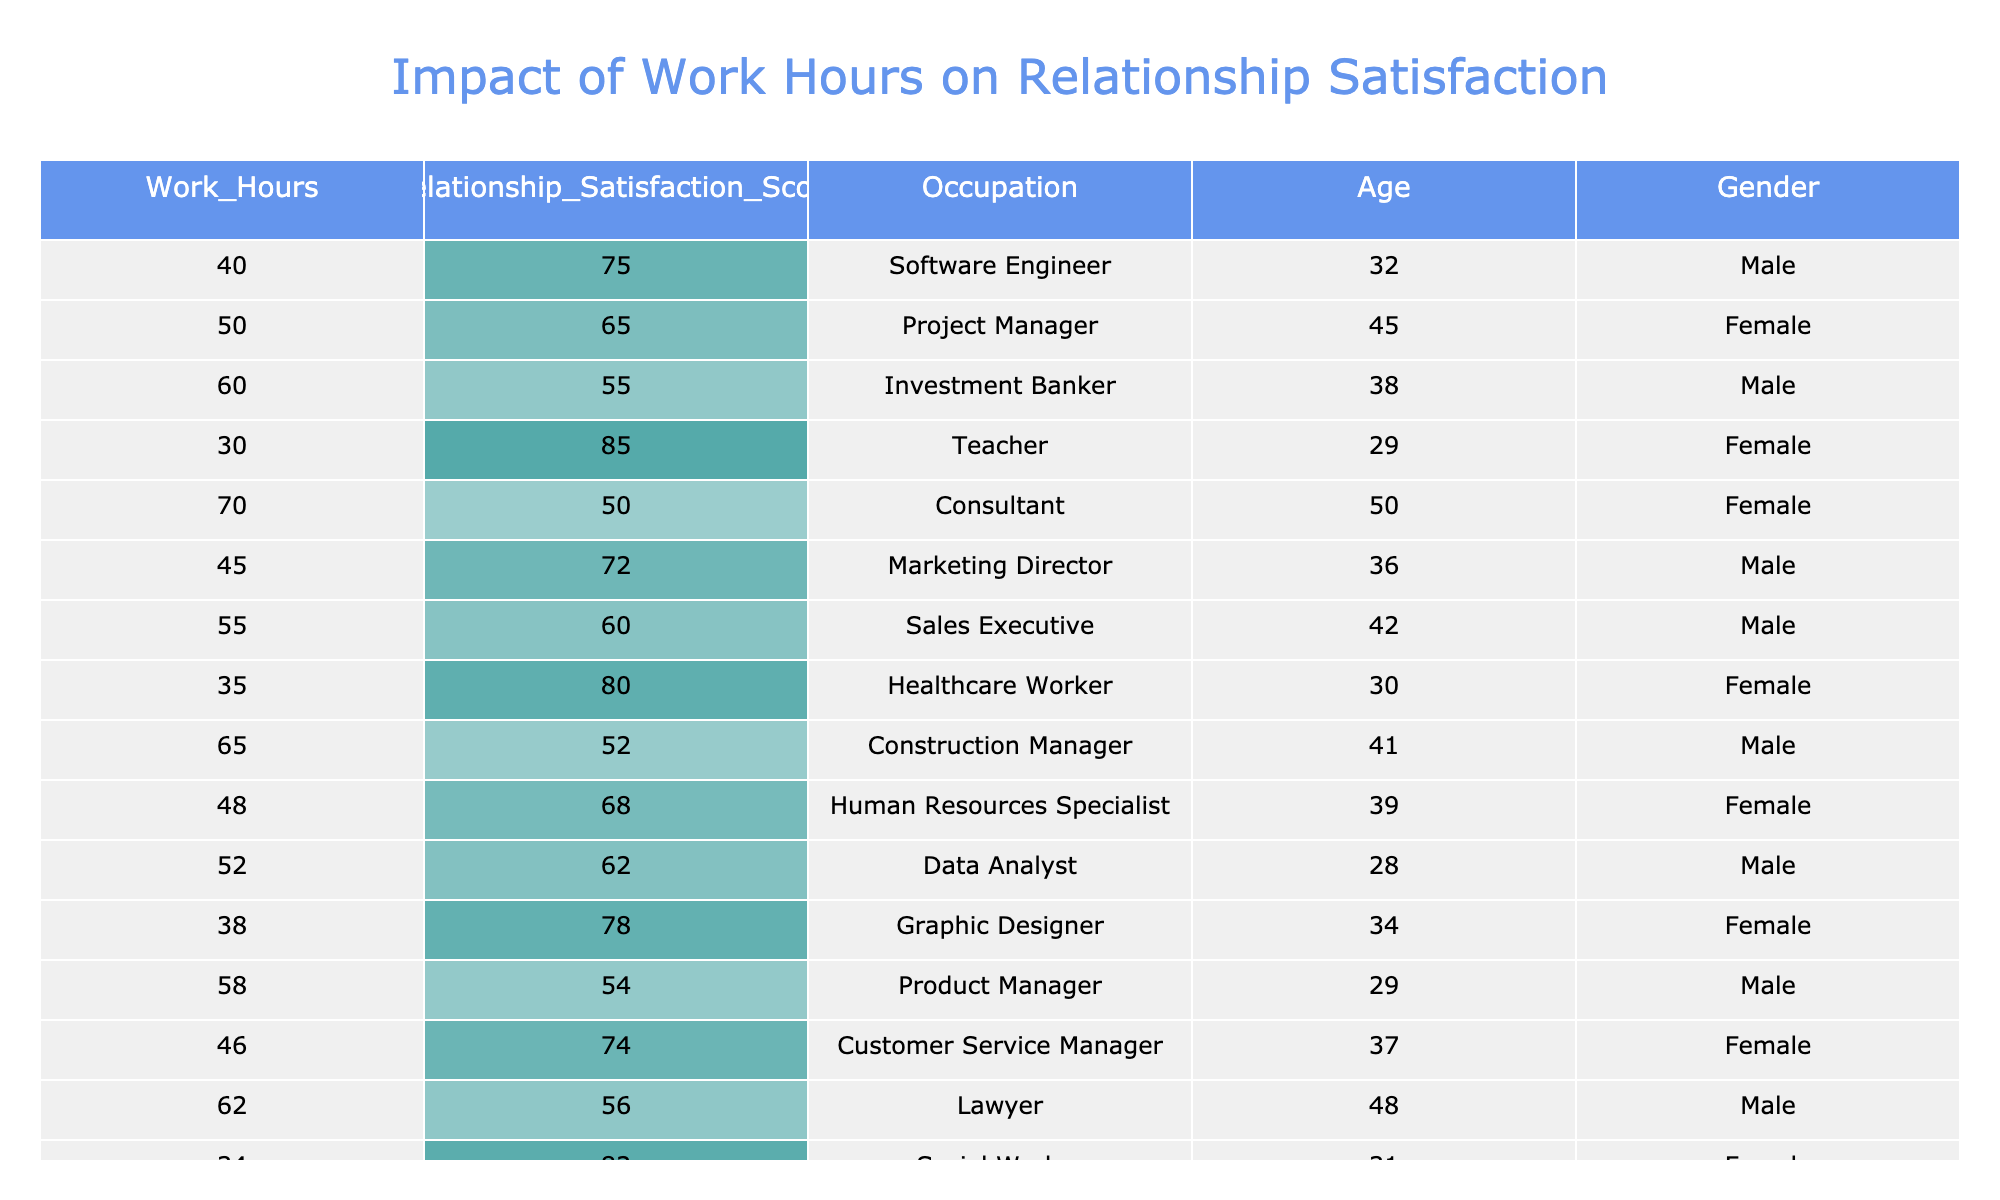What is the highest Relationship Satisfaction Score, and which occupation does it belong to? The highest score in the table is 85, which can be located in the first column of the respective row. The occupation associated with this score is "Teacher."
Answer: 85, Teacher What is the average Relationship Satisfaction Score for individuals working more than 50 hours? First, identify the scores for those who work more than 50 hours: 65, 55, 50, 68, 62, 56, and 54. Adding these gives 65 + 55 + 50 + 68 + 62 + 56 + 54 = 410. There are 7 individuals, so the average is 410 / 7 = 58.57.
Answer: 58.57 Is there a notable relationship between the number of work hours and relationship satisfaction scores? By observing the table, higher work hours generally coincide with lower relationship satisfaction scores, indicating that increased work hours may negatively impact satisfaction.
Answer: Yes How many males have a Relationship Satisfaction Score above 70? Review the scores for males: 75, 65, 55, 72, 60, 52, 54, and 56. The scores above 70 are 75 and 72, which gives a total of 2 males.
Answer: 2 What is the difference in Relationship Satisfaction Scores between the individual with the highest and lowest scores? The highest score is 85 (Teacher) and the lowest score is 50 (Consultant). The difference is calculated as 85 - 50 = 35.
Answer: 35 How does the average Relationship Satisfaction Score for females compare to that of males? For females, the scores are 65, 80, 85, 68, 78, 74, 82, which sum to 457. There are 7 females giving an average of 457 / 7 = 65.29. Males have scores 75, 55, 72, 60, 52, 54, 56, which sum to 504. The average for males is 504 / 7 = 72. So, females score lower on average than males.
Answer: Males are higher What percentage of individuals reported a Relationship Satisfaction Score below 60? Looking at the scores, those below 60 are 55, 50, 55, and 54, totaling 4 individuals. There are 16 individuals overall, so the percentage is (4/16) * 100 = 25%.
Answer: 25% How many occupations have Relationship Satisfaction Scores above the average score of the dataset? First, calculate the average score. The cumulative score is 72 total from all, with 16 participants, giving an average of 72/16 = 64.5. The occupations above this score are "Software Engineer," "Teacher," "Marketing Director," "Healthcare Worker," "Human Resources Specialist," "Graphic Designer," "Customer Service Manager," and "Social Worker," leading to 8 occupations.
Answer: 8 